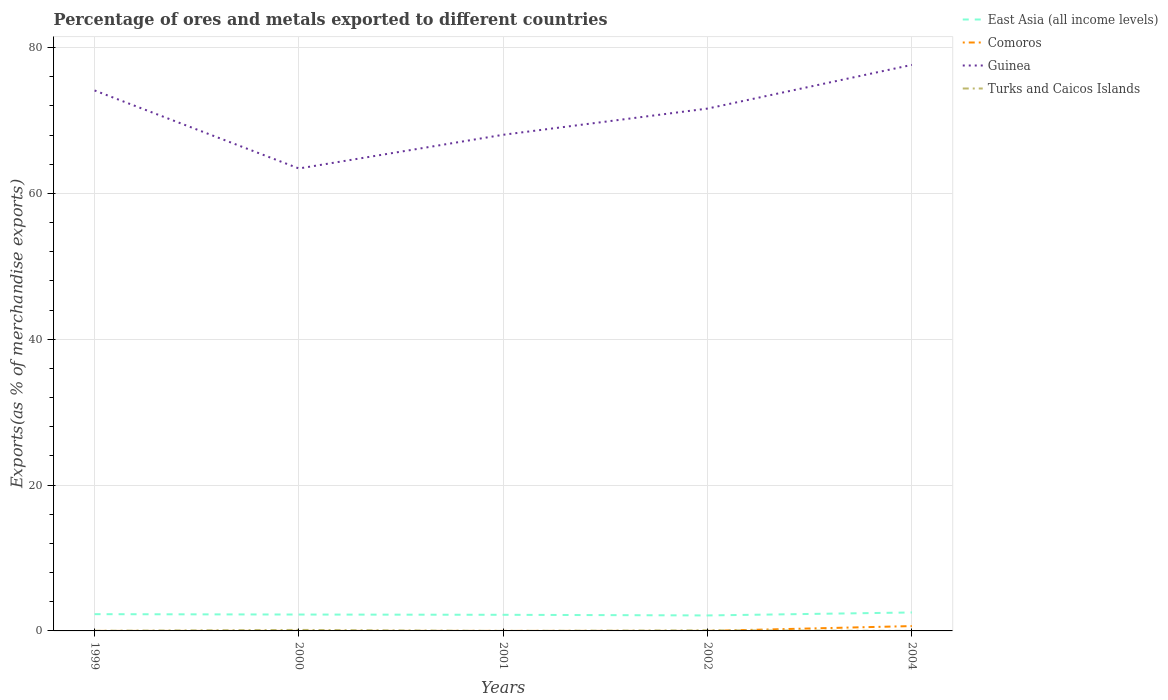How many different coloured lines are there?
Provide a succinct answer. 4. Does the line corresponding to East Asia (all income levels) intersect with the line corresponding to Guinea?
Provide a short and direct response. No. Is the number of lines equal to the number of legend labels?
Your response must be concise. Yes. Across all years, what is the maximum percentage of exports to different countries in Guinea?
Give a very brief answer. 63.41. What is the total percentage of exports to different countries in Comoros in the graph?
Provide a short and direct response. -0. What is the difference between the highest and the second highest percentage of exports to different countries in Turks and Caicos Islands?
Keep it short and to the point. 0.14. Is the percentage of exports to different countries in East Asia (all income levels) strictly greater than the percentage of exports to different countries in Turks and Caicos Islands over the years?
Your answer should be very brief. No. How many lines are there?
Offer a terse response. 4. How many years are there in the graph?
Offer a very short reply. 5. What is the difference between two consecutive major ticks on the Y-axis?
Offer a very short reply. 20. Are the values on the major ticks of Y-axis written in scientific E-notation?
Provide a succinct answer. No. Does the graph contain any zero values?
Make the answer very short. No. Where does the legend appear in the graph?
Offer a very short reply. Top right. How many legend labels are there?
Provide a succinct answer. 4. What is the title of the graph?
Ensure brevity in your answer.  Percentage of ores and metals exported to different countries. What is the label or title of the X-axis?
Your answer should be very brief. Years. What is the label or title of the Y-axis?
Your response must be concise. Exports(as % of merchandise exports). What is the Exports(as % of merchandise exports) of East Asia (all income levels) in 1999?
Your response must be concise. 2.3. What is the Exports(as % of merchandise exports) in Comoros in 1999?
Give a very brief answer. 0. What is the Exports(as % of merchandise exports) in Guinea in 1999?
Offer a very short reply. 74.11. What is the Exports(as % of merchandise exports) in Turks and Caicos Islands in 1999?
Offer a very short reply. 0.02. What is the Exports(as % of merchandise exports) of East Asia (all income levels) in 2000?
Offer a terse response. 2.25. What is the Exports(as % of merchandise exports) of Comoros in 2000?
Offer a very short reply. 0. What is the Exports(as % of merchandise exports) of Guinea in 2000?
Give a very brief answer. 63.41. What is the Exports(as % of merchandise exports) in Turks and Caicos Islands in 2000?
Provide a succinct answer. 0.14. What is the Exports(as % of merchandise exports) in East Asia (all income levels) in 2001?
Give a very brief answer. 2.21. What is the Exports(as % of merchandise exports) of Comoros in 2001?
Offer a very short reply. 0.01. What is the Exports(as % of merchandise exports) in Guinea in 2001?
Give a very brief answer. 68.03. What is the Exports(as % of merchandise exports) in Turks and Caicos Islands in 2001?
Your answer should be compact. 0. What is the Exports(as % of merchandise exports) in East Asia (all income levels) in 2002?
Provide a succinct answer. 2.12. What is the Exports(as % of merchandise exports) of Comoros in 2002?
Your answer should be compact. 0. What is the Exports(as % of merchandise exports) in Guinea in 2002?
Your answer should be compact. 71.63. What is the Exports(as % of merchandise exports) of Turks and Caicos Islands in 2002?
Provide a succinct answer. 0.08. What is the Exports(as % of merchandise exports) of East Asia (all income levels) in 2004?
Offer a very short reply. 2.53. What is the Exports(as % of merchandise exports) in Comoros in 2004?
Your response must be concise. 0.67. What is the Exports(as % of merchandise exports) in Guinea in 2004?
Offer a terse response. 77.62. What is the Exports(as % of merchandise exports) in Turks and Caicos Islands in 2004?
Offer a terse response. 0. Across all years, what is the maximum Exports(as % of merchandise exports) in East Asia (all income levels)?
Offer a very short reply. 2.53. Across all years, what is the maximum Exports(as % of merchandise exports) of Comoros?
Give a very brief answer. 0.67. Across all years, what is the maximum Exports(as % of merchandise exports) of Guinea?
Offer a very short reply. 77.62. Across all years, what is the maximum Exports(as % of merchandise exports) of Turks and Caicos Islands?
Ensure brevity in your answer.  0.14. Across all years, what is the minimum Exports(as % of merchandise exports) of East Asia (all income levels)?
Provide a short and direct response. 2.12. Across all years, what is the minimum Exports(as % of merchandise exports) in Comoros?
Your answer should be very brief. 0. Across all years, what is the minimum Exports(as % of merchandise exports) of Guinea?
Offer a very short reply. 63.41. Across all years, what is the minimum Exports(as % of merchandise exports) in Turks and Caicos Islands?
Your answer should be compact. 0. What is the total Exports(as % of merchandise exports) in East Asia (all income levels) in the graph?
Your answer should be compact. 11.41. What is the total Exports(as % of merchandise exports) in Comoros in the graph?
Provide a succinct answer. 0.68. What is the total Exports(as % of merchandise exports) of Guinea in the graph?
Keep it short and to the point. 354.8. What is the total Exports(as % of merchandise exports) in Turks and Caicos Islands in the graph?
Offer a very short reply. 0.24. What is the difference between the Exports(as % of merchandise exports) of East Asia (all income levels) in 1999 and that in 2000?
Ensure brevity in your answer.  0.05. What is the difference between the Exports(as % of merchandise exports) of Comoros in 1999 and that in 2000?
Provide a succinct answer. -0. What is the difference between the Exports(as % of merchandise exports) in Guinea in 1999 and that in 2000?
Give a very brief answer. 10.7. What is the difference between the Exports(as % of merchandise exports) of Turks and Caicos Islands in 1999 and that in 2000?
Give a very brief answer. -0.12. What is the difference between the Exports(as % of merchandise exports) of East Asia (all income levels) in 1999 and that in 2001?
Offer a terse response. 0.09. What is the difference between the Exports(as % of merchandise exports) of Comoros in 1999 and that in 2001?
Provide a succinct answer. -0. What is the difference between the Exports(as % of merchandise exports) of Guinea in 1999 and that in 2001?
Make the answer very short. 6.08. What is the difference between the Exports(as % of merchandise exports) in Turks and Caicos Islands in 1999 and that in 2001?
Offer a very short reply. 0.02. What is the difference between the Exports(as % of merchandise exports) in East Asia (all income levels) in 1999 and that in 2002?
Give a very brief answer. 0.18. What is the difference between the Exports(as % of merchandise exports) in Comoros in 1999 and that in 2002?
Your answer should be very brief. -0. What is the difference between the Exports(as % of merchandise exports) of Guinea in 1999 and that in 2002?
Offer a very short reply. 2.48. What is the difference between the Exports(as % of merchandise exports) of Turks and Caicos Islands in 1999 and that in 2002?
Ensure brevity in your answer.  -0.07. What is the difference between the Exports(as % of merchandise exports) of East Asia (all income levels) in 1999 and that in 2004?
Your answer should be compact. -0.23. What is the difference between the Exports(as % of merchandise exports) of Comoros in 1999 and that in 2004?
Make the answer very short. -0.66. What is the difference between the Exports(as % of merchandise exports) of Guinea in 1999 and that in 2004?
Your answer should be compact. -3.51. What is the difference between the Exports(as % of merchandise exports) of Turks and Caicos Islands in 1999 and that in 2004?
Offer a very short reply. 0.02. What is the difference between the Exports(as % of merchandise exports) in East Asia (all income levels) in 2000 and that in 2001?
Offer a terse response. 0.04. What is the difference between the Exports(as % of merchandise exports) of Comoros in 2000 and that in 2001?
Offer a terse response. -0. What is the difference between the Exports(as % of merchandise exports) in Guinea in 2000 and that in 2001?
Make the answer very short. -4.62. What is the difference between the Exports(as % of merchandise exports) in Turks and Caicos Islands in 2000 and that in 2001?
Give a very brief answer. 0.14. What is the difference between the Exports(as % of merchandise exports) of East Asia (all income levels) in 2000 and that in 2002?
Your answer should be compact. 0.12. What is the difference between the Exports(as % of merchandise exports) of Comoros in 2000 and that in 2002?
Offer a very short reply. 0. What is the difference between the Exports(as % of merchandise exports) of Guinea in 2000 and that in 2002?
Your answer should be compact. -8.21. What is the difference between the Exports(as % of merchandise exports) in Turks and Caicos Islands in 2000 and that in 2002?
Ensure brevity in your answer.  0.06. What is the difference between the Exports(as % of merchandise exports) of East Asia (all income levels) in 2000 and that in 2004?
Offer a very short reply. -0.28. What is the difference between the Exports(as % of merchandise exports) of Comoros in 2000 and that in 2004?
Provide a short and direct response. -0.66. What is the difference between the Exports(as % of merchandise exports) in Guinea in 2000 and that in 2004?
Give a very brief answer. -14.21. What is the difference between the Exports(as % of merchandise exports) of Turks and Caicos Islands in 2000 and that in 2004?
Your answer should be compact. 0.14. What is the difference between the Exports(as % of merchandise exports) in East Asia (all income levels) in 2001 and that in 2002?
Offer a very short reply. 0.09. What is the difference between the Exports(as % of merchandise exports) in Comoros in 2001 and that in 2002?
Ensure brevity in your answer.  0. What is the difference between the Exports(as % of merchandise exports) of Guinea in 2001 and that in 2002?
Offer a terse response. -3.59. What is the difference between the Exports(as % of merchandise exports) of Turks and Caicos Islands in 2001 and that in 2002?
Give a very brief answer. -0.08. What is the difference between the Exports(as % of merchandise exports) in East Asia (all income levels) in 2001 and that in 2004?
Your answer should be compact. -0.32. What is the difference between the Exports(as % of merchandise exports) in Comoros in 2001 and that in 2004?
Your answer should be very brief. -0.66. What is the difference between the Exports(as % of merchandise exports) of Guinea in 2001 and that in 2004?
Keep it short and to the point. -9.58. What is the difference between the Exports(as % of merchandise exports) of Turks and Caicos Islands in 2001 and that in 2004?
Offer a very short reply. -0. What is the difference between the Exports(as % of merchandise exports) of East Asia (all income levels) in 2002 and that in 2004?
Your response must be concise. -0.41. What is the difference between the Exports(as % of merchandise exports) of Comoros in 2002 and that in 2004?
Ensure brevity in your answer.  -0.66. What is the difference between the Exports(as % of merchandise exports) in Guinea in 2002 and that in 2004?
Give a very brief answer. -5.99. What is the difference between the Exports(as % of merchandise exports) of Turks and Caicos Islands in 2002 and that in 2004?
Provide a succinct answer. 0.08. What is the difference between the Exports(as % of merchandise exports) of East Asia (all income levels) in 1999 and the Exports(as % of merchandise exports) of Comoros in 2000?
Give a very brief answer. 2.29. What is the difference between the Exports(as % of merchandise exports) in East Asia (all income levels) in 1999 and the Exports(as % of merchandise exports) in Guinea in 2000?
Provide a succinct answer. -61.11. What is the difference between the Exports(as % of merchandise exports) in East Asia (all income levels) in 1999 and the Exports(as % of merchandise exports) in Turks and Caicos Islands in 2000?
Ensure brevity in your answer.  2.16. What is the difference between the Exports(as % of merchandise exports) in Comoros in 1999 and the Exports(as % of merchandise exports) in Guinea in 2000?
Your answer should be very brief. -63.41. What is the difference between the Exports(as % of merchandise exports) of Comoros in 1999 and the Exports(as % of merchandise exports) of Turks and Caicos Islands in 2000?
Offer a very short reply. -0.14. What is the difference between the Exports(as % of merchandise exports) of Guinea in 1999 and the Exports(as % of merchandise exports) of Turks and Caicos Islands in 2000?
Your response must be concise. 73.97. What is the difference between the Exports(as % of merchandise exports) of East Asia (all income levels) in 1999 and the Exports(as % of merchandise exports) of Comoros in 2001?
Provide a short and direct response. 2.29. What is the difference between the Exports(as % of merchandise exports) in East Asia (all income levels) in 1999 and the Exports(as % of merchandise exports) in Guinea in 2001?
Ensure brevity in your answer.  -65.74. What is the difference between the Exports(as % of merchandise exports) of East Asia (all income levels) in 1999 and the Exports(as % of merchandise exports) of Turks and Caicos Islands in 2001?
Offer a very short reply. 2.3. What is the difference between the Exports(as % of merchandise exports) in Comoros in 1999 and the Exports(as % of merchandise exports) in Guinea in 2001?
Ensure brevity in your answer.  -68.03. What is the difference between the Exports(as % of merchandise exports) in Comoros in 1999 and the Exports(as % of merchandise exports) in Turks and Caicos Islands in 2001?
Provide a succinct answer. 0. What is the difference between the Exports(as % of merchandise exports) in Guinea in 1999 and the Exports(as % of merchandise exports) in Turks and Caicos Islands in 2001?
Give a very brief answer. 74.11. What is the difference between the Exports(as % of merchandise exports) in East Asia (all income levels) in 1999 and the Exports(as % of merchandise exports) in Comoros in 2002?
Offer a terse response. 2.3. What is the difference between the Exports(as % of merchandise exports) in East Asia (all income levels) in 1999 and the Exports(as % of merchandise exports) in Guinea in 2002?
Offer a very short reply. -69.33. What is the difference between the Exports(as % of merchandise exports) of East Asia (all income levels) in 1999 and the Exports(as % of merchandise exports) of Turks and Caicos Islands in 2002?
Give a very brief answer. 2.22. What is the difference between the Exports(as % of merchandise exports) in Comoros in 1999 and the Exports(as % of merchandise exports) in Guinea in 2002?
Your answer should be compact. -71.62. What is the difference between the Exports(as % of merchandise exports) of Comoros in 1999 and the Exports(as % of merchandise exports) of Turks and Caicos Islands in 2002?
Your answer should be compact. -0.08. What is the difference between the Exports(as % of merchandise exports) of Guinea in 1999 and the Exports(as % of merchandise exports) of Turks and Caicos Islands in 2002?
Your answer should be compact. 74.03. What is the difference between the Exports(as % of merchandise exports) of East Asia (all income levels) in 1999 and the Exports(as % of merchandise exports) of Comoros in 2004?
Offer a very short reply. 1.63. What is the difference between the Exports(as % of merchandise exports) in East Asia (all income levels) in 1999 and the Exports(as % of merchandise exports) in Guinea in 2004?
Provide a short and direct response. -75.32. What is the difference between the Exports(as % of merchandise exports) in East Asia (all income levels) in 1999 and the Exports(as % of merchandise exports) in Turks and Caicos Islands in 2004?
Offer a very short reply. 2.3. What is the difference between the Exports(as % of merchandise exports) of Comoros in 1999 and the Exports(as % of merchandise exports) of Guinea in 2004?
Ensure brevity in your answer.  -77.62. What is the difference between the Exports(as % of merchandise exports) of Comoros in 1999 and the Exports(as % of merchandise exports) of Turks and Caicos Islands in 2004?
Offer a very short reply. 0. What is the difference between the Exports(as % of merchandise exports) of Guinea in 1999 and the Exports(as % of merchandise exports) of Turks and Caicos Islands in 2004?
Your answer should be very brief. 74.11. What is the difference between the Exports(as % of merchandise exports) in East Asia (all income levels) in 2000 and the Exports(as % of merchandise exports) in Comoros in 2001?
Make the answer very short. 2.24. What is the difference between the Exports(as % of merchandise exports) in East Asia (all income levels) in 2000 and the Exports(as % of merchandise exports) in Guinea in 2001?
Offer a terse response. -65.79. What is the difference between the Exports(as % of merchandise exports) of East Asia (all income levels) in 2000 and the Exports(as % of merchandise exports) of Turks and Caicos Islands in 2001?
Provide a short and direct response. 2.25. What is the difference between the Exports(as % of merchandise exports) of Comoros in 2000 and the Exports(as % of merchandise exports) of Guinea in 2001?
Your response must be concise. -68.03. What is the difference between the Exports(as % of merchandise exports) in Comoros in 2000 and the Exports(as % of merchandise exports) in Turks and Caicos Islands in 2001?
Your answer should be compact. 0. What is the difference between the Exports(as % of merchandise exports) of Guinea in 2000 and the Exports(as % of merchandise exports) of Turks and Caicos Islands in 2001?
Provide a short and direct response. 63.41. What is the difference between the Exports(as % of merchandise exports) of East Asia (all income levels) in 2000 and the Exports(as % of merchandise exports) of Comoros in 2002?
Provide a succinct answer. 2.25. What is the difference between the Exports(as % of merchandise exports) of East Asia (all income levels) in 2000 and the Exports(as % of merchandise exports) of Guinea in 2002?
Keep it short and to the point. -69.38. What is the difference between the Exports(as % of merchandise exports) in East Asia (all income levels) in 2000 and the Exports(as % of merchandise exports) in Turks and Caicos Islands in 2002?
Your response must be concise. 2.16. What is the difference between the Exports(as % of merchandise exports) in Comoros in 2000 and the Exports(as % of merchandise exports) in Guinea in 2002?
Provide a short and direct response. -71.62. What is the difference between the Exports(as % of merchandise exports) in Comoros in 2000 and the Exports(as % of merchandise exports) in Turks and Caicos Islands in 2002?
Keep it short and to the point. -0.08. What is the difference between the Exports(as % of merchandise exports) of Guinea in 2000 and the Exports(as % of merchandise exports) of Turks and Caicos Islands in 2002?
Give a very brief answer. 63.33. What is the difference between the Exports(as % of merchandise exports) of East Asia (all income levels) in 2000 and the Exports(as % of merchandise exports) of Comoros in 2004?
Keep it short and to the point. 1.58. What is the difference between the Exports(as % of merchandise exports) of East Asia (all income levels) in 2000 and the Exports(as % of merchandise exports) of Guinea in 2004?
Offer a terse response. -75.37. What is the difference between the Exports(as % of merchandise exports) of East Asia (all income levels) in 2000 and the Exports(as % of merchandise exports) of Turks and Caicos Islands in 2004?
Keep it short and to the point. 2.25. What is the difference between the Exports(as % of merchandise exports) of Comoros in 2000 and the Exports(as % of merchandise exports) of Guinea in 2004?
Provide a short and direct response. -77.61. What is the difference between the Exports(as % of merchandise exports) of Comoros in 2000 and the Exports(as % of merchandise exports) of Turks and Caicos Islands in 2004?
Your answer should be compact. 0. What is the difference between the Exports(as % of merchandise exports) in Guinea in 2000 and the Exports(as % of merchandise exports) in Turks and Caicos Islands in 2004?
Provide a short and direct response. 63.41. What is the difference between the Exports(as % of merchandise exports) in East Asia (all income levels) in 2001 and the Exports(as % of merchandise exports) in Comoros in 2002?
Offer a terse response. 2.21. What is the difference between the Exports(as % of merchandise exports) in East Asia (all income levels) in 2001 and the Exports(as % of merchandise exports) in Guinea in 2002?
Your response must be concise. -69.42. What is the difference between the Exports(as % of merchandise exports) of East Asia (all income levels) in 2001 and the Exports(as % of merchandise exports) of Turks and Caicos Islands in 2002?
Make the answer very short. 2.13. What is the difference between the Exports(as % of merchandise exports) of Comoros in 2001 and the Exports(as % of merchandise exports) of Guinea in 2002?
Your answer should be compact. -71.62. What is the difference between the Exports(as % of merchandise exports) in Comoros in 2001 and the Exports(as % of merchandise exports) in Turks and Caicos Islands in 2002?
Provide a succinct answer. -0.08. What is the difference between the Exports(as % of merchandise exports) in Guinea in 2001 and the Exports(as % of merchandise exports) in Turks and Caicos Islands in 2002?
Offer a very short reply. 67.95. What is the difference between the Exports(as % of merchandise exports) of East Asia (all income levels) in 2001 and the Exports(as % of merchandise exports) of Comoros in 2004?
Your answer should be compact. 1.55. What is the difference between the Exports(as % of merchandise exports) in East Asia (all income levels) in 2001 and the Exports(as % of merchandise exports) in Guinea in 2004?
Provide a succinct answer. -75.41. What is the difference between the Exports(as % of merchandise exports) in East Asia (all income levels) in 2001 and the Exports(as % of merchandise exports) in Turks and Caicos Islands in 2004?
Give a very brief answer. 2.21. What is the difference between the Exports(as % of merchandise exports) of Comoros in 2001 and the Exports(as % of merchandise exports) of Guinea in 2004?
Offer a very short reply. -77.61. What is the difference between the Exports(as % of merchandise exports) of Comoros in 2001 and the Exports(as % of merchandise exports) of Turks and Caicos Islands in 2004?
Make the answer very short. 0. What is the difference between the Exports(as % of merchandise exports) of Guinea in 2001 and the Exports(as % of merchandise exports) of Turks and Caicos Islands in 2004?
Ensure brevity in your answer.  68.03. What is the difference between the Exports(as % of merchandise exports) of East Asia (all income levels) in 2002 and the Exports(as % of merchandise exports) of Comoros in 2004?
Keep it short and to the point. 1.46. What is the difference between the Exports(as % of merchandise exports) in East Asia (all income levels) in 2002 and the Exports(as % of merchandise exports) in Guinea in 2004?
Give a very brief answer. -75.5. What is the difference between the Exports(as % of merchandise exports) in East Asia (all income levels) in 2002 and the Exports(as % of merchandise exports) in Turks and Caicos Islands in 2004?
Provide a succinct answer. 2.12. What is the difference between the Exports(as % of merchandise exports) in Comoros in 2002 and the Exports(as % of merchandise exports) in Guinea in 2004?
Your answer should be very brief. -77.62. What is the difference between the Exports(as % of merchandise exports) in Comoros in 2002 and the Exports(as % of merchandise exports) in Turks and Caicos Islands in 2004?
Give a very brief answer. 0. What is the difference between the Exports(as % of merchandise exports) of Guinea in 2002 and the Exports(as % of merchandise exports) of Turks and Caicos Islands in 2004?
Your response must be concise. 71.63. What is the average Exports(as % of merchandise exports) of East Asia (all income levels) per year?
Ensure brevity in your answer.  2.28. What is the average Exports(as % of merchandise exports) of Comoros per year?
Keep it short and to the point. 0.14. What is the average Exports(as % of merchandise exports) in Guinea per year?
Ensure brevity in your answer.  70.96. What is the average Exports(as % of merchandise exports) in Turks and Caicos Islands per year?
Provide a succinct answer. 0.05. In the year 1999, what is the difference between the Exports(as % of merchandise exports) of East Asia (all income levels) and Exports(as % of merchandise exports) of Comoros?
Your response must be concise. 2.3. In the year 1999, what is the difference between the Exports(as % of merchandise exports) in East Asia (all income levels) and Exports(as % of merchandise exports) in Guinea?
Your response must be concise. -71.81. In the year 1999, what is the difference between the Exports(as % of merchandise exports) of East Asia (all income levels) and Exports(as % of merchandise exports) of Turks and Caicos Islands?
Give a very brief answer. 2.28. In the year 1999, what is the difference between the Exports(as % of merchandise exports) in Comoros and Exports(as % of merchandise exports) in Guinea?
Keep it short and to the point. -74.11. In the year 1999, what is the difference between the Exports(as % of merchandise exports) in Comoros and Exports(as % of merchandise exports) in Turks and Caicos Islands?
Your response must be concise. -0.02. In the year 1999, what is the difference between the Exports(as % of merchandise exports) of Guinea and Exports(as % of merchandise exports) of Turks and Caicos Islands?
Ensure brevity in your answer.  74.09. In the year 2000, what is the difference between the Exports(as % of merchandise exports) of East Asia (all income levels) and Exports(as % of merchandise exports) of Comoros?
Ensure brevity in your answer.  2.24. In the year 2000, what is the difference between the Exports(as % of merchandise exports) in East Asia (all income levels) and Exports(as % of merchandise exports) in Guinea?
Offer a very short reply. -61.16. In the year 2000, what is the difference between the Exports(as % of merchandise exports) in East Asia (all income levels) and Exports(as % of merchandise exports) in Turks and Caicos Islands?
Your answer should be compact. 2.11. In the year 2000, what is the difference between the Exports(as % of merchandise exports) of Comoros and Exports(as % of merchandise exports) of Guinea?
Offer a very short reply. -63.41. In the year 2000, what is the difference between the Exports(as % of merchandise exports) in Comoros and Exports(as % of merchandise exports) in Turks and Caicos Islands?
Offer a very short reply. -0.13. In the year 2000, what is the difference between the Exports(as % of merchandise exports) in Guinea and Exports(as % of merchandise exports) in Turks and Caicos Islands?
Offer a very short reply. 63.27. In the year 2001, what is the difference between the Exports(as % of merchandise exports) in East Asia (all income levels) and Exports(as % of merchandise exports) in Comoros?
Provide a short and direct response. 2.21. In the year 2001, what is the difference between the Exports(as % of merchandise exports) of East Asia (all income levels) and Exports(as % of merchandise exports) of Guinea?
Your answer should be compact. -65.82. In the year 2001, what is the difference between the Exports(as % of merchandise exports) of East Asia (all income levels) and Exports(as % of merchandise exports) of Turks and Caicos Islands?
Offer a terse response. 2.21. In the year 2001, what is the difference between the Exports(as % of merchandise exports) of Comoros and Exports(as % of merchandise exports) of Guinea?
Make the answer very short. -68.03. In the year 2001, what is the difference between the Exports(as % of merchandise exports) in Comoros and Exports(as % of merchandise exports) in Turks and Caicos Islands?
Your answer should be very brief. 0.01. In the year 2001, what is the difference between the Exports(as % of merchandise exports) of Guinea and Exports(as % of merchandise exports) of Turks and Caicos Islands?
Ensure brevity in your answer.  68.03. In the year 2002, what is the difference between the Exports(as % of merchandise exports) in East Asia (all income levels) and Exports(as % of merchandise exports) in Comoros?
Provide a succinct answer. 2.12. In the year 2002, what is the difference between the Exports(as % of merchandise exports) in East Asia (all income levels) and Exports(as % of merchandise exports) in Guinea?
Keep it short and to the point. -69.5. In the year 2002, what is the difference between the Exports(as % of merchandise exports) of East Asia (all income levels) and Exports(as % of merchandise exports) of Turks and Caicos Islands?
Ensure brevity in your answer.  2.04. In the year 2002, what is the difference between the Exports(as % of merchandise exports) of Comoros and Exports(as % of merchandise exports) of Guinea?
Offer a very short reply. -71.62. In the year 2002, what is the difference between the Exports(as % of merchandise exports) of Comoros and Exports(as % of merchandise exports) of Turks and Caicos Islands?
Offer a very short reply. -0.08. In the year 2002, what is the difference between the Exports(as % of merchandise exports) in Guinea and Exports(as % of merchandise exports) in Turks and Caicos Islands?
Ensure brevity in your answer.  71.54. In the year 2004, what is the difference between the Exports(as % of merchandise exports) of East Asia (all income levels) and Exports(as % of merchandise exports) of Comoros?
Keep it short and to the point. 1.87. In the year 2004, what is the difference between the Exports(as % of merchandise exports) of East Asia (all income levels) and Exports(as % of merchandise exports) of Guinea?
Ensure brevity in your answer.  -75.09. In the year 2004, what is the difference between the Exports(as % of merchandise exports) in East Asia (all income levels) and Exports(as % of merchandise exports) in Turks and Caicos Islands?
Provide a short and direct response. 2.53. In the year 2004, what is the difference between the Exports(as % of merchandise exports) of Comoros and Exports(as % of merchandise exports) of Guinea?
Offer a very short reply. -76.95. In the year 2004, what is the difference between the Exports(as % of merchandise exports) of Comoros and Exports(as % of merchandise exports) of Turks and Caicos Islands?
Keep it short and to the point. 0.66. In the year 2004, what is the difference between the Exports(as % of merchandise exports) in Guinea and Exports(as % of merchandise exports) in Turks and Caicos Islands?
Offer a terse response. 77.62. What is the ratio of the Exports(as % of merchandise exports) of East Asia (all income levels) in 1999 to that in 2000?
Give a very brief answer. 1.02. What is the ratio of the Exports(as % of merchandise exports) in Comoros in 1999 to that in 2000?
Offer a very short reply. 0.45. What is the ratio of the Exports(as % of merchandise exports) in Guinea in 1999 to that in 2000?
Provide a short and direct response. 1.17. What is the ratio of the Exports(as % of merchandise exports) in Turks and Caicos Islands in 1999 to that in 2000?
Keep it short and to the point. 0.12. What is the ratio of the Exports(as % of merchandise exports) in East Asia (all income levels) in 1999 to that in 2001?
Offer a terse response. 1.04. What is the ratio of the Exports(as % of merchandise exports) of Comoros in 1999 to that in 2001?
Give a very brief answer. 0.36. What is the ratio of the Exports(as % of merchandise exports) in Guinea in 1999 to that in 2001?
Provide a succinct answer. 1.09. What is the ratio of the Exports(as % of merchandise exports) of Turks and Caicos Islands in 1999 to that in 2001?
Give a very brief answer. 81.53. What is the ratio of the Exports(as % of merchandise exports) in East Asia (all income levels) in 1999 to that in 2002?
Offer a terse response. 1.08. What is the ratio of the Exports(as % of merchandise exports) in Comoros in 1999 to that in 2002?
Provide a succinct answer. 0.91. What is the ratio of the Exports(as % of merchandise exports) of Guinea in 1999 to that in 2002?
Ensure brevity in your answer.  1.03. What is the ratio of the Exports(as % of merchandise exports) of Turks and Caicos Islands in 1999 to that in 2002?
Offer a very short reply. 0.21. What is the ratio of the Exports(as % of merchandise exports) in East Asia (all income levels) in 1999 to that in 2004?
Give a very brief answer. 0.91. What is the ratio of the Exports(as % of merchandise exports) in Comoros in 1999 to that in 2004?
Make the answer very short. 0. What is the ratio of the Exports(as % of merchandise exports) in Guinea in 1999 to that in 2004?
Offer a very short reply. 0.95. What is the ratio of the Exports(as % of merchandise exports) of Turks and Caicos Islands in 1999 to that in 2004?
Your answer should be compact. 18.82. What is the ratio of the Exports(as % of merchandise exports) of East Asia (all income levels) in 2000 to that in 2001?
Your response must be concise. 1.02. What is the ratio of the Exports(as % of merchandise exports) in Comoros in 2000 to that in 2001?
Keep it short and to the point. 0.81. What is the ratio of the Exports(as % of merchandise exports) of Guinea in 2000 to that in 2001?
Your answer should be compact. 0.93. What is the ratio of the Exports(as % of merchandise exports) of Turks and Caicos Islands in 2000 to that in 2001?
Give a very brief answer. 653.05. What is the ratio of the Exports(as % of merchandise exports) of East Asia (all income levels) in 2000 to that in 2002?
Your answer should be compact. 1.06. What is the ratio of the Exports(as % of merchandise exports) of Comoros in 2000 to that in 2002?
Your response must be concise. 2.03. What is the ratio of the Exports(as % of merchandise exports) of Guinea in 2000 to that in 2002?
Give a very brief answer. 0.89. What is the ratio of the Exports(as % of merchandise exports) of Turks and Caicos Islands in 2000 to that in 2002?
Your response must be concise. 1.68. What is the ratio of the Exports(as % of merchandise exports) in East Asia (all income levels) in 2000 to that in 2004?
Offer a terse response. 0.89. What is the ratio of the Exports(as % of merchandise exports) in Comoros in 2000 to that in 2004?
Provide a succinct answer. 0.01. What is the ratio of the Exports(as % of merchandise exports) of Guinea in 2000 to that in 2004?
Your answer should be compact. 0.82. What is the ratio of the Exports(as % of merchandise exports) of Turks and Caicos Islands in 2000 to that in 2004?
Give a very brief answer. 150.75. What is the ratio of the Exports(as % of merchandise exports) in East Asia (all income levels) in 2001 to that in 2002?
Make the answer very short. 1.04. What is the ratio of the Exports(as % of merchandise exports) of Comoros in 2001 to that in 2002?
Give a very brief answer. 2.51. What is the ratio of the Exports(as % of merchandise exports) in Guinea in 2001 to that in 2002?
Keep it short and to the point. 0.95. What is the ratio of the Exports(as % of merchandise exports) in Turks and Caicos Islands in 2001 to that in 2002?
Give a very brief answer. 0. What is the ratio of the Exports(as % of merchandise exports) in East Asia (all income levels) in 2001 to that in 2004?
Provide a succinct answer. 0.87. What is the ratio of the Exports(as % of merchandise exports) in Comoros in 2001 to that in 2004?
Your answer should be compact. 0.01. What is the ratio of the Exports(as % of merchandise exports) in Guinea in 2001 to that in 2004?
Provide a succinct answer. 0.88. What is the ratio of the Exports(as % of merchandise exports) in Turks and Caicos Islands in 2001 to that in 2004?
Ensure brevity in your answer.  0.23. What is the ratio of the Exports(as % of merchandise exports) in East Asia (all income levels) in 2002 to that in 2004?
Offer a very short reply. 0.84. What is the ratio of the Exports(as % of merchandise exports) of Comoros in 2002 to that in 2004?
Keep it short and to the point. 0. What is the ratio of the Exports(as % of merchandise exports) of Guinea in 2002 to that in 2004?
Make the answer very short. 0.92. What is the ratio of the Exports(as % of merchandise exports) of Turks and Caicos Islands in 2002 to that in 2004?
Ensure brevity in your answer.  89.67. What is the difference between the highest and the second highest Exports(as % of merchandise exports) in East Asia (all income levels)?
Give a very brief answer. 0.23. What is the difference between the highest and the second highest Exports(as % of merchandise exports) in Comoros?
Your response must be concise. 0.66. What is the difference between the highest and the second highest Exports(as % of merchandise exports) in Guinea?
Your answer should be very brief. 3.51. What is the difference between the highest and the second highest Exports(as % of merchandise exports) of Turks and Caicos Islands?
Provide a succinct answer. 0.06. What is the difference between the highest and the lowest Exports(as % of merchandise exports) of East Asia (all income levels)?
Make the answer very short. 0.41. What is the difference between the highest and the lowest Exports(as % of merchandise exports) of Comoros?
Offer a very short reply. 0.66. What is the difference between the highest and the lowest Exports(as % of merchandise exports) in Guinea?
Your response must be concise. 14.21. What is the difference between the highest and the lowest Exports(as % of merchandise exports) of Turks and Caicos Islands?
Offer a terse response. 0.14. 